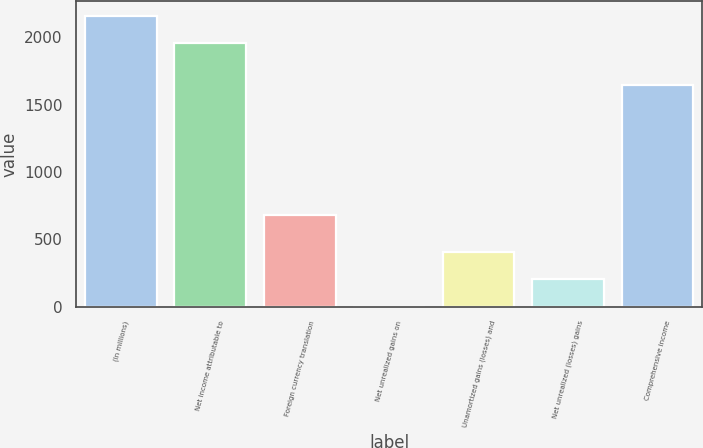<chart> <loc_0><loc_0><loc_500><loc_500><bar_chart><fcel>(In millions)<fcel>Net income attributable to<fcel>Foreign currency translation<fcel>Net unrealized gains on<fcel>Unamortized gains (losses) and<fcel>Net unrealized (losses) gains<fcel>Comprehensive income<nl><fcel>2162.1<fcel>1961<fcel>682<fcel>2<fcel>404.2<fcel>203.1<fcel>1649<nl></chart> 